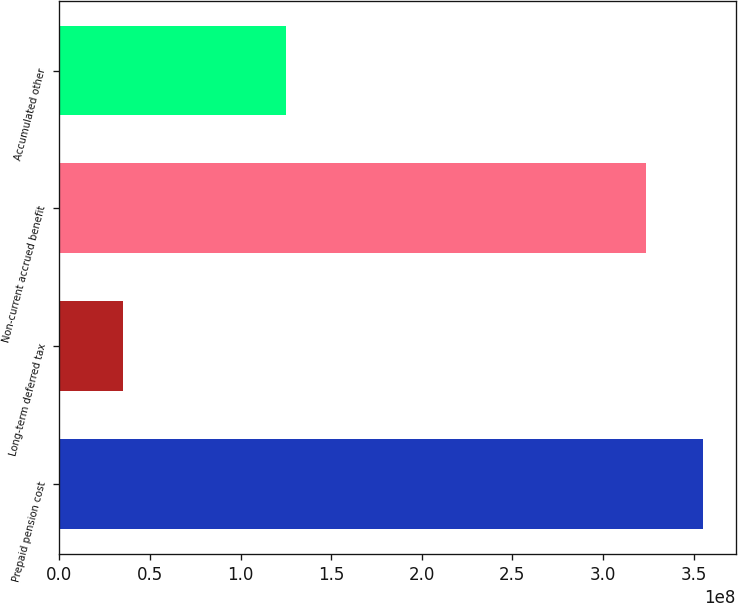Convert chart. <chart><loc_0><loc_0><loc_500><loc_500><bar_chart><fcel>Prepaid pension cost<fcel>Long-term deferred tax<fcel>Non-current accrued benefit<fcel>Accumulated other<nl><fcel>3.55384e+08<fcel>3.5132e+07<fcel>3.23658e+08<fcel>1.25265e+08<nl></chart> 